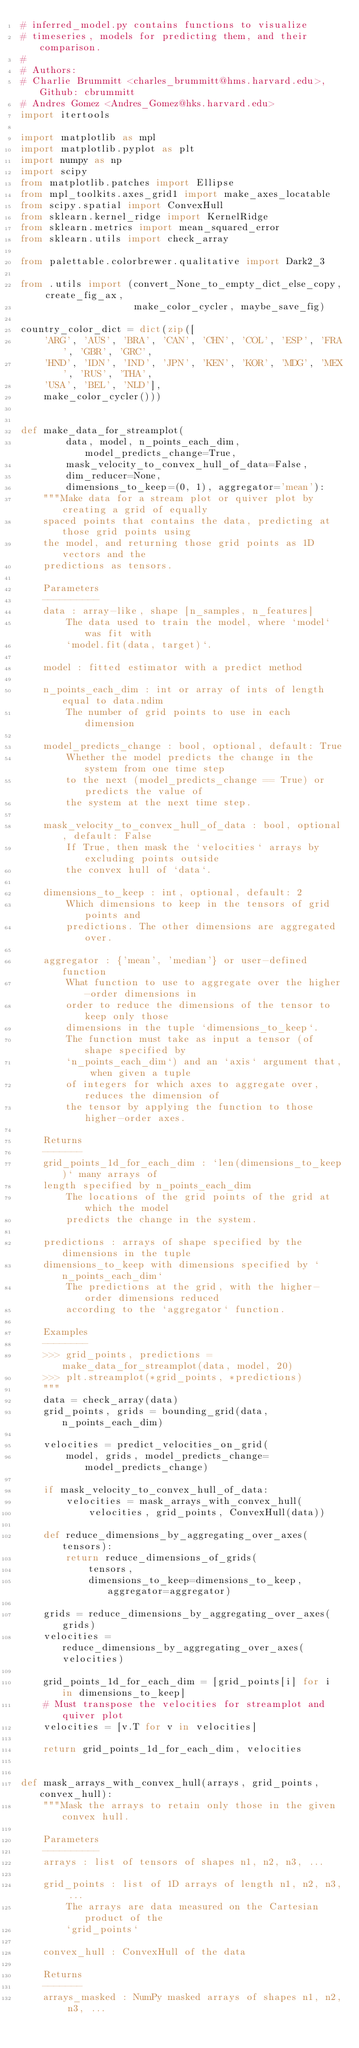Convert code to text. <code><loc_0><loc_0><loc_500><loc_500><_Python_># inferred_model.py contains functions to visualize
# timeseries, models for predicting them, and their comparison.
#
# Authors:
# Charlie Brummitt <charles_brummitt@hms.harvard.edu>, Github: cbrummitt
# Andres Gomez <Andres_Gomez@hks.harvard.edu>
import itertools

import matplotlib as mpl
import matplotlib.pyplot as plt
import numpy as np
import scipy
from matplotlib.patches import Ellipse
from mpl_toolkits.axes_grid1 import make_axes_locatable
from scipy.spatial import ConvexHull
from sklearn.kernel_ridge import KernelRidge
from sklearn.metrics import mean_squared_error
from sklearn.utils import check_array

from palettable.colorbrewer.qualitative import Dark2_3

from .utils import (convert_None_to_empty_dict_else_copy, create_fig_ax,
                    make_color_cycler, maybe_save_fig)

country_color_dict = dict(zip([
    'ARG', 'AUS', 'BRA', 'CAN', 'CHN', 'COL', 'ESP', 'FRA', 'GBR', 'GRC',
    'HND', 'IDN', 'IND', 'JPN', 'KEN', 'KOR', 'MDG', 'MEX', 'RUS', 'THA',
    'USA', 'BEL', 'NLD'],
    make_color_cycler()))


def make_data_for_streamplot(
        data, model, n_points_each_dim, model_predicts_change=True,
        mask_velocity_to_convex_hull_of_data=False,
        dim_reducer=None,
        dimensions_to_keep=(0, 1), aggregator='mean'):
    """Make data for a stream plot or quiver plot by creating a grid of equally
    spaced points that contains the data, predicting at those grid points using
    the model, and returning those grid points as 1D vectors and the
    predictions as tensors.

    Parameters
    ----------
    data : array-like, shape [n_samples, n_features]
        The data used to train the model, where `model` was fit with
        `model.fit(data, target)`.

    model : fitted estimator with a predict method

    n_points_each_dim : int or array of ints of length equal to data.ndim
        The number of grid points to use in each dimension

    model_predicts_change : bool, optional, default: True
        Whether the model predicts the change in the system from one time step
        to the next (model_predicts_change == True) or predicts the value of
        the system at the next time step.

    mask_velocity_to_convex_hull_of_data : bool, optional, default: False
        If True, then mask the `velocities` arrays by excluding points outside
        the convex hull of `data`.

    dimensions_to_keep : int, optional, default: 2
        Which dimensions to keep in the tensors of grid points and
        predictions. The other dimensions are aggregated over.

    aggregator : {'mean', 'median'} or user-defined function
        What function to use to aggregate over the higher-order dimensions in
        order to reduce the dimensions of the tensor to keep only those
        dimensions in the tuple `dimensions_to_keep`.
        The function must take as input a tensor (of shape specified by
        `n_points_each_dim`) and an `axis` argument that, when given a tuple
        of integers for which axes to aggregate over, reduces the dimension of
        the tensor by applying the function to those higher-order axes.

    Returns
    -------
    grid_points_1d_for_each_dim : `len(dimensions_to_keep)` many arrays of
    length specified by n_points_each_dim
        The locations of the grid points of the grid at which the model
        predicts the change in the system.

    predictions : arrays of shape specified by the dimensions in the tuple
    dimensions_to_keep with dimensions specified by `n_points_each_dim`
        The predictions at the grid, with the higher-order dimensions reduced
        according to the `aggregator` function.

    Examples
    --------
    >>> grid_points, predictions = make_data_for_streamplot(data, model, 20)
    >>> plt.streamplot(*grid_points, *predictions)
    """
    data = check_array(data)
    grid_points, grids = bounding_grid(data, n_points_each_dim)

    velocities = predict_velocities_on_grid(
        model, grids, model_predicts_change=model_predicts_change)

    if mask_velocity_to_convex_hull_of_data:
        velocities = mask_arrays_with_convex_hull(
            velocities, grid_points, ConvexHull(data))

    def reduce_dimensions_by_aggregating_over_axes(tensors):
        return reduce_dimensions_of_grids(
            tensors,
            dimensions_to_keep=dimensions_to_keep, aggregator=aggregator)

    grids = reduce_dimensions_by_aggregating_over_axes(grids)
    velocities = reduce_dimensions_by_aggregating_over_axes(velocities)

    grid_points_1d_for_each_dim = [grid_points[i] for i in dimensions_to_keep]
    # Must transpose the velocities for streamplot and quiver plot
    velocities = [v.T for v in velocities]

    return grid_points_1d_for_each_dim, velocities


def mask_arrays_with_convex_hull(arrays, grid_points, convex_hull):
    """Mask the arrays to retain only those in the given convex hull.

    Parameters
    ----------
    arrays : list of tensors of shapes n1, n2, n3, ...

    grid_points : list of 1D arrays of length n1, n2, n3, ...
        The arrays are data measured on the Cartesian product of the
        `grid_points`

    convex_hull : ConvexHull of the data

    Returns
    -------
    arrays_masked : NumPy masked arrays of shapes n1, n2, n3, ...</code> 